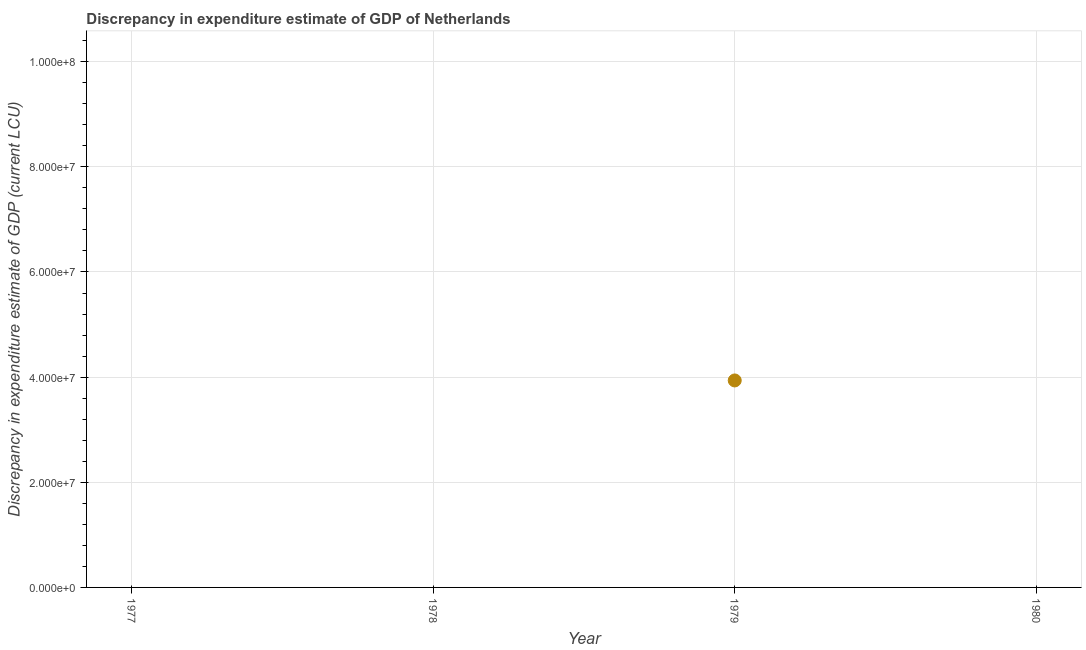What is the discrepancy in expenditure estimate of gdp in 1978?
Your response must be concise. 0. Across all years, what is the maximum discrepancy in expenditure estimate of gdp?
Provide a short and direct response. 3.94e+07. In which year was the discrepancy in expenditure estimate of gdp maximum?
Keep it short and to the point. 1979. What is the sum of the discrepancy in expenditure estimate of gdp?
Make the answer very short. 3.94e+07. What is the average discrepancy in expenditure estimate of gdp per year?
Your answer should be very brief. 9.84e+06. What is the median discrepancy in expenditure estimate of gdp?
Give a very brief answer. 0. What is the difference between the highest and the lowest discrepancy in expenditure estimate of gdp?
Your response must be concise. 3.94e+07. In how many years, is the discrepancy in expenditure estimate of gdp greater than the average discrepancy in expenditure estimate of gdp taken over all years?
Offer a very short reply. 1. How many years are there in the graph?
Provide a succinct answer. 4. What is the title of the graph?
Provide a short and direct response. Discrepancy in expenditure estimate of GDP of Netherlands. What is the label or title of the X-axis?
Give a very brief answer. Year. What is the label or title of the Y-axis?
Ensure brevity in your answer.  Discrepancy in expenditure estimate of GDP (current LCU). What is the Discrepancy in expenditure estimate of GDP (current LCU) in 1977?
Provide a short and direct response. 0. What is the Discrepancy in expenditure estimate of GDP (current LCU) in 1978?
Give a very brief answer. 0. What is the Discrepancy in expenditure estimate of GDP (current LCU) in 1979?
Offer a terse response. 3.94e+07. What is the Discrepancy in expenditure estimate of GDP (current LCU) in 1980?
Make the answer very short. 0. 